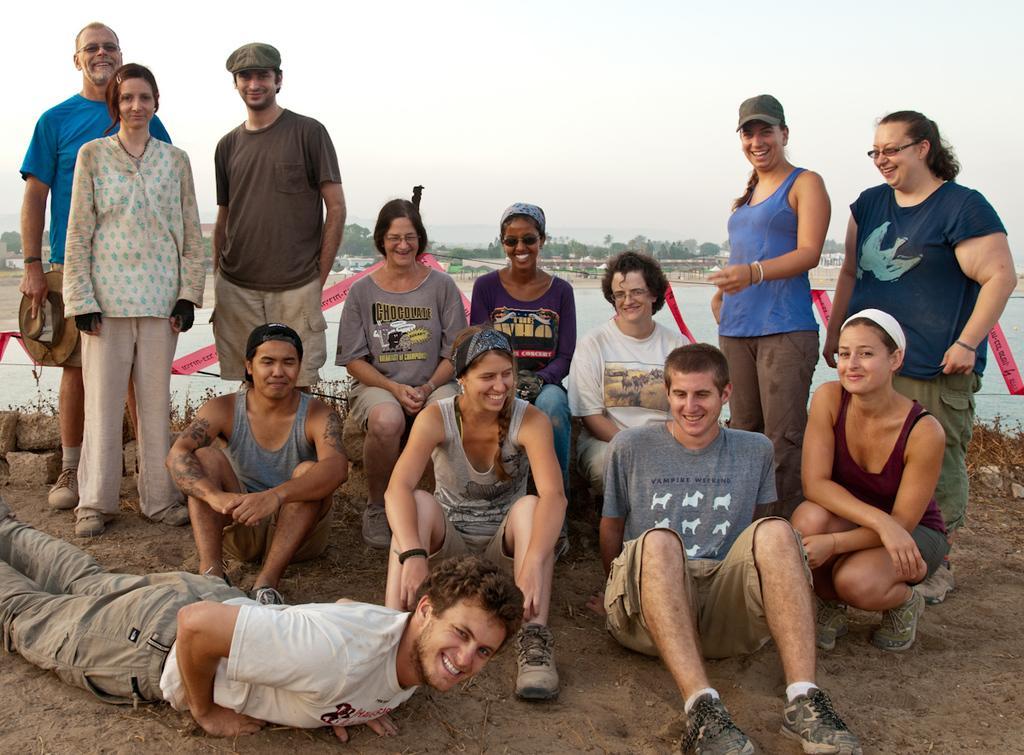Could you give a brief overview of what you see in this image? This picture describes about group of people, few are standing, few are seated and a man is lying on the ground, behind them we can see few rocks, water, and trees. 